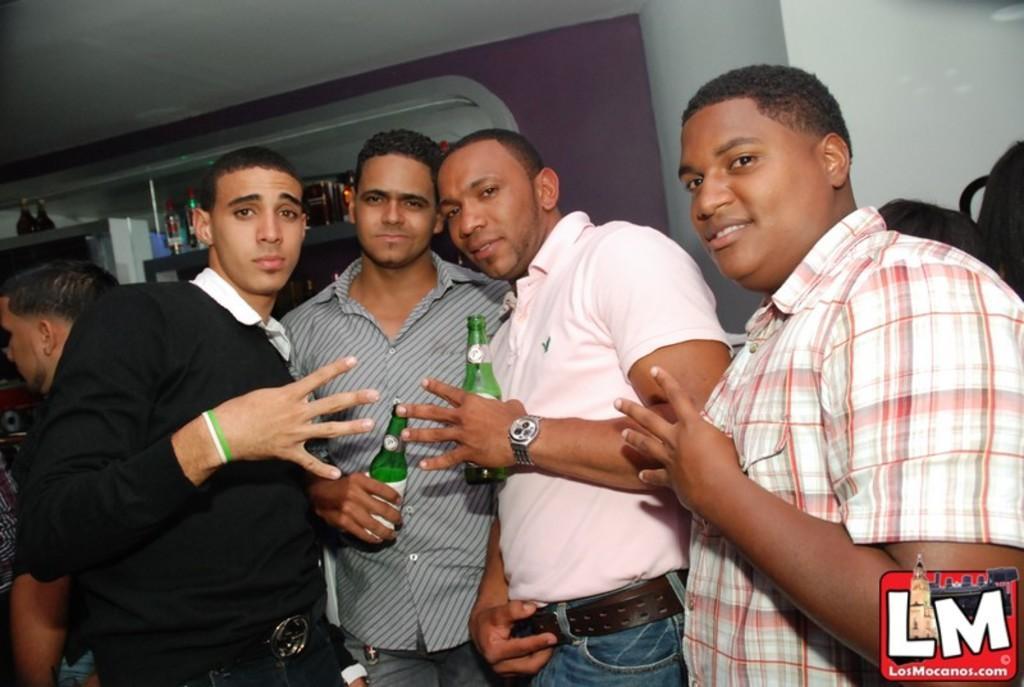How would you summarize this image in a sentence or two? This picture describes about group of people, in the middle of the image we can see two men, they are holding bottles, in the background we can see few more bottles in the racks, and also we can see a logo at the right bottom of the image. 